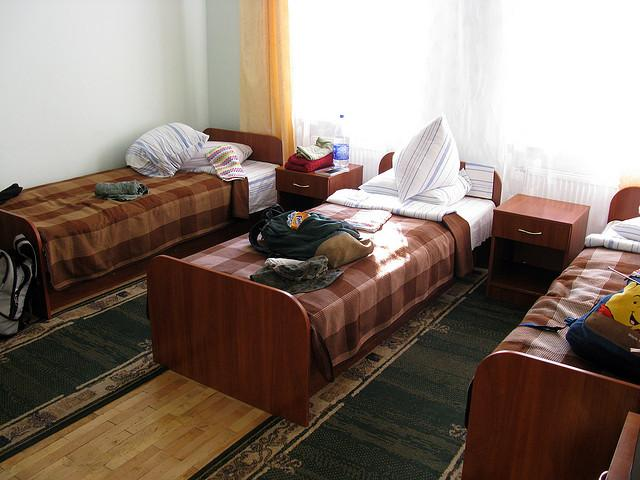What color is the face of the cartoon character on the backpack on the far right bed? Please explain your reasoning. yellow. It's winnie the pooh 